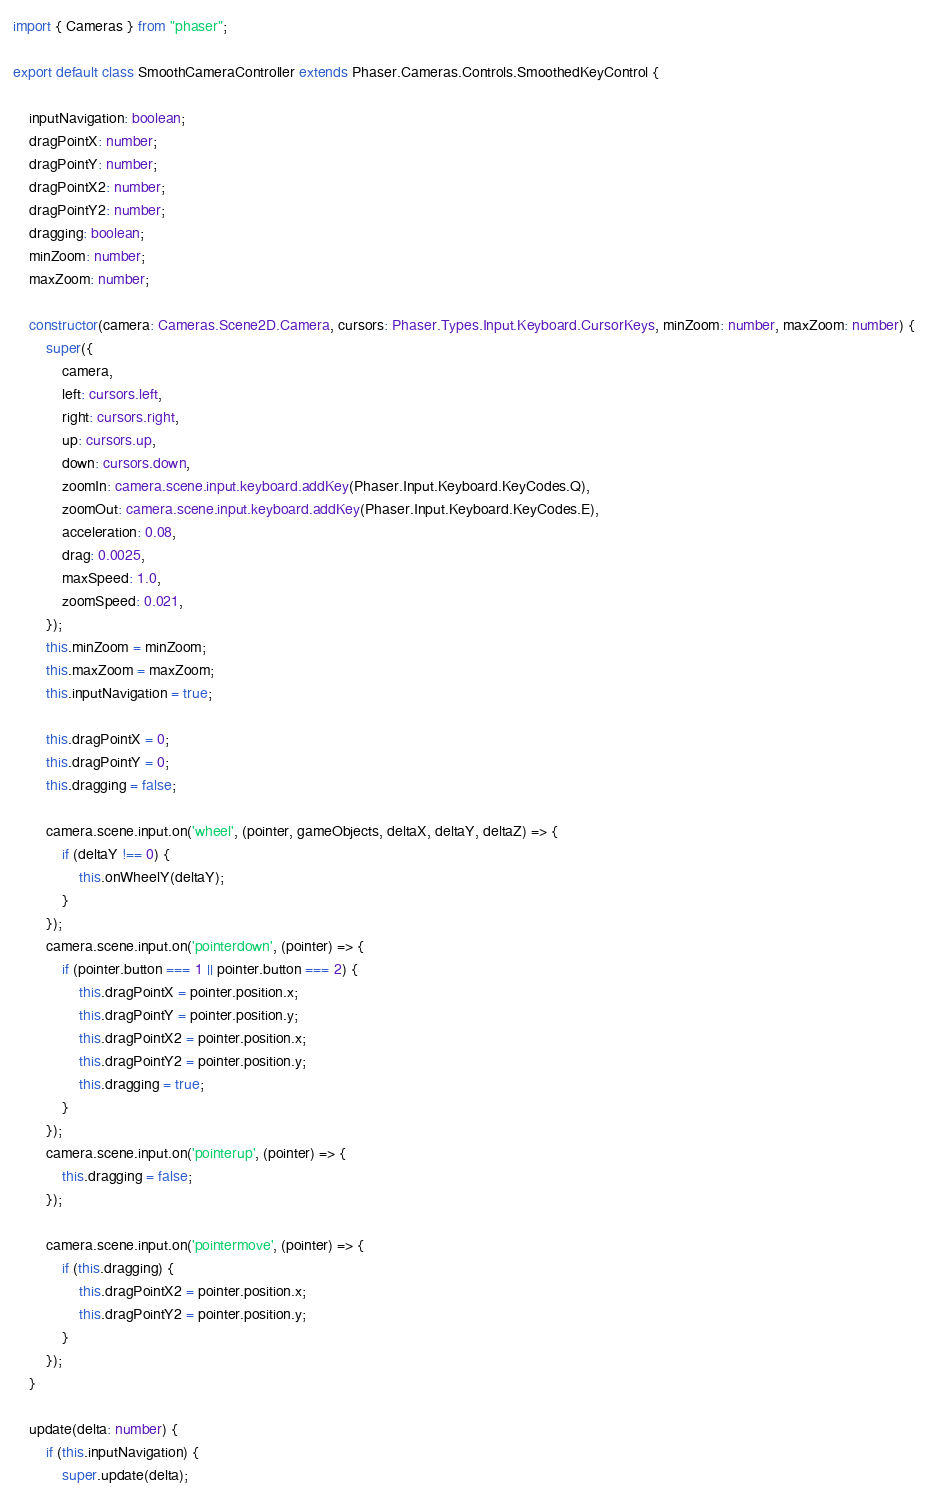<code> <loc_0><loc_0><loc_500><loc_500><_TypeScript_>import { Cameras } from "phaser";

export default class SmoothCameraController extends Phaser.Cameras.Controls.SmoothedKeyControl {

    inputNavigation: boolean;
    dragPointX: number;
    dragPointY: number;
    dragPointX2: number;
    dragPointY2: number;
    dragging: boolean;
    minZoom: number;
    maxZoom: number;

    constructor(camera: Cameras.Scene2D.Camera, cursors: Phaser.Types.Input.Keyboard.CursorKeys, minZoom: number, maxZoom: number) {
        super({
            camera,
            left: cursors.left,
            right: cursors.right,
            up: cursors.up,
            down: cursors.down,
            zoomIn: camera.scene.input.keyboard.addKey(Phaser.Input.Keyboard.KeyCodes.Q),
            zoomOut: camera.scene.input.keyboard.addKey(Phaser.Input.Keyboard.KeyCodes.E),
            acceleration: 0.08,
            drag: 0.0025,
            maxSpeed: 1.0,
            zoomSpeed: 0.021,
        });
        this.minZoom = minZoom;
        this.maxZoom = maxZoom; 
        this.inputNavigation = true;

        this.dragPointX = 0;
        this.dragPointY = 0;
        this.dragging = false;

        camera.scene.input.on('wheel', (pointer, gameObjects, deltaX, deltaY, deltaZ) => {
            if (deltaY !== 0) {
                this.onWheelY(deltaY); 
            }
        });
        camera.scene.input.on('pointerdown', (pointer) => {
            if (pointer.button === 1 || pointer.button === 2) {
                this.dragPointX = pointer.position.x;
                this.dragPointY = pointer.position.y;
                this.dragPointX2 = pointer.position.x;
                this.dragPointY2 = pointer.position.y;
                this.dragging = true;
            }
        });
        camera.scene.input.on('pointerup', (pointer) => {
            this.dragging = false;
        });

        camera.scene.input.on('pointermove', (pointer) => {
            if (this.dragging) {
                this.dragPointX2 = pointer.position.x;
                this.dragPointY2 = pointer.position.y;
            }
        });
    }

    update(delta: number) {
        if (this.inputNavigation) {
            super.update(delta);</code> 